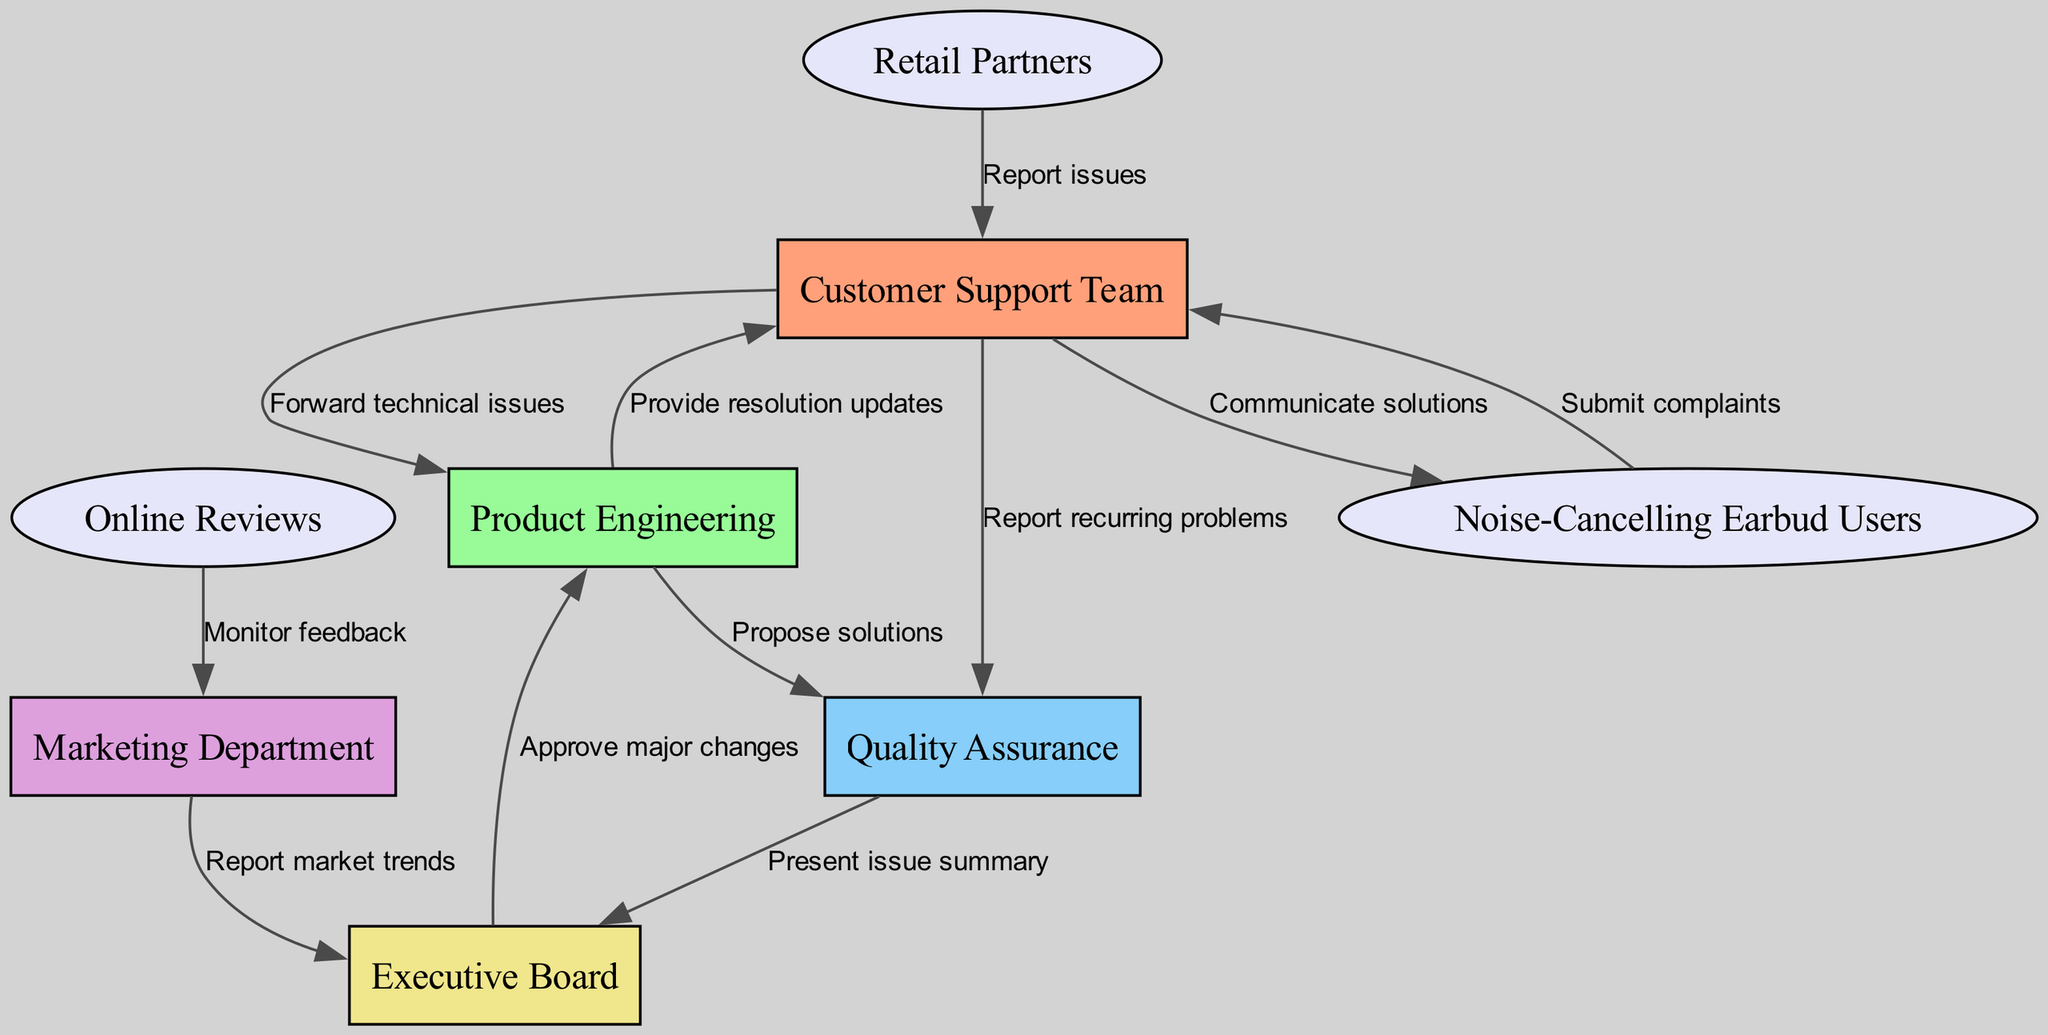What is the starting point in the feedback flow? The starting point of the feedback flow is "Noise-Cancelling Earbud Users" who submit complaints. This node is the first one to initiate contact within the diagram, indicating where the process begins.
Answer: Noise-Cancelling Earbud Users How many total nodes are there in the diagram? By counting all the distinct nodes displayed in the diagram, we find that there are eight nodes in total. This includes all the entities involved in the customer feedback flow.
Answer: Eight Who reports issues to the Customer Support Team? The "Retail Partners" are the ones who report issues to the Customer Support Team, as indicated by the directed edge connecting these two nodes.
Answer: Retail Partners What department monitors feedback from Online Reviews? The "Marketing Department" monitors feedback coming from Online Reviews. This relationship is shown through the direct connection from Online Reviews to Marketing Department in the diagram.
Answer: Marketing Department Which team receives updates on resolutions from Product Engineering? The "Customer Support Team" receives updates on resolutions from the Product Engineering department, as indicated by the directed arrow from Product Engineering to Customer Support Team in the flow.
Answer: Customer Support Team How many edges are there connecting the nodes in the diagram? The total number of edges, which represent the connections between nodes, is eleven. Counting them reveals that there are eleven directed relationships depicted in the diagram.
Answer: Eleven What is the final step in the resolution process? The final step in the resolution process is "Communicate solutions" to "Noise-Cancelling Earbud Users." This indicates that the feedback flow culminates in delivering solutions back to the customers who raised the issues.
Answer: Communicate solutions What presentation is made to the Executive Board? A "Present issue summary" is made to the Executive Board by the Quality Assurance team, according to the directed edge indicated in the diagram. This illustrates the flow of important information to top-level executives.
Answer: Present issue summary Which team is responsible for proposing solutions? The "Product Engineering" team is responsible for proposing solutions, as indicated by the edge directed from Product Engineering to Quality Assurance in the feedback flow.
Answer: Product Engineering 